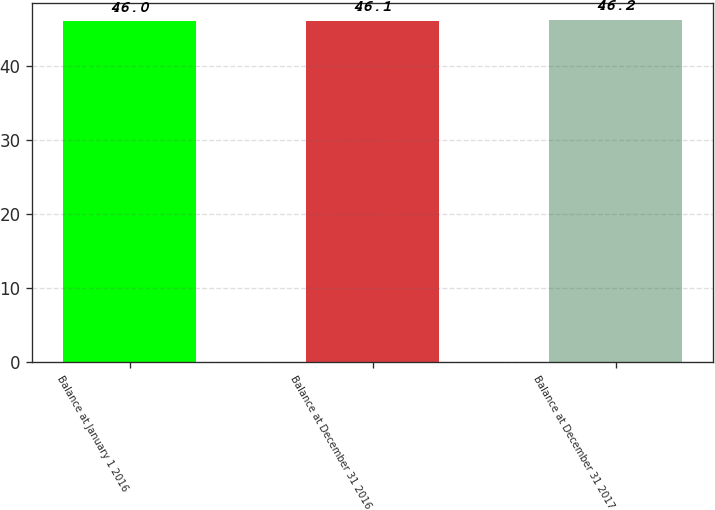Convert chart to OTSL. <chart><loc_0><loc_0><loc_500><loc_500><bar_chart><fcel>Balance at January 1 2016<fcel>Balance at December 31 2016<fcel>Balance at December 31 2017<nl><fcel>46<fcel>46.1<fcel>46.2<nl></chart> 